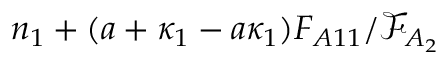Convert formula to latex. <formula><loc_0><loc_0><loc_500><loc_500>n _ { 1 } + ( a + \kappa _ { 1 } - a \kappa _ { 1 } ) F _ { A 1 1 } / \mathcal { F } _ { A _ { 2 } }</formula> 